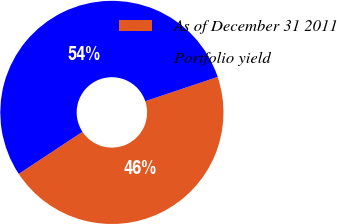<chart> <loc_0><loc_0><loc_500><loc_500><pie_chart><fcel>As of December 31 2011<fcel>Portfolio yield<nl><fcel>45.87%<fcel>54.13%<nl></chart> 